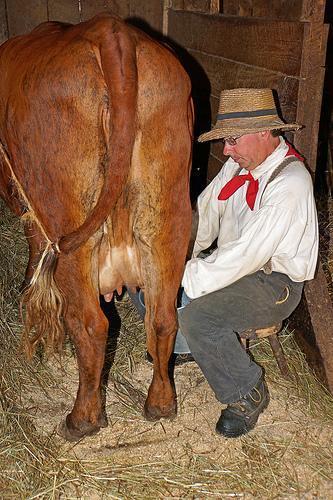How many cows are there?
Give a very brief answer. 1. 